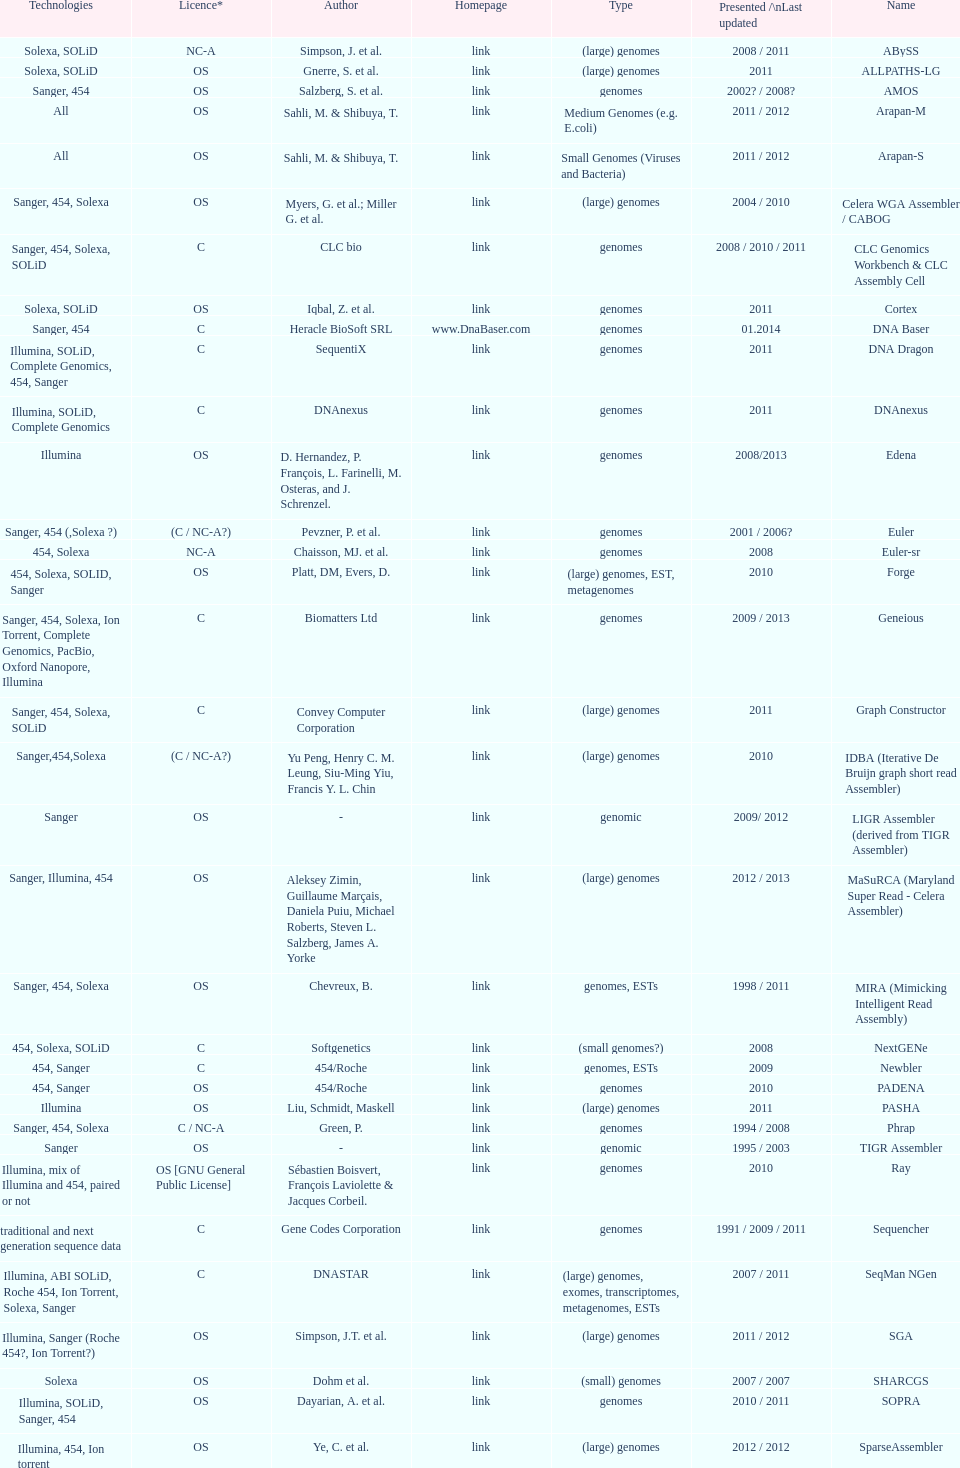What is the newest presentation or updated? DNA Baser. 